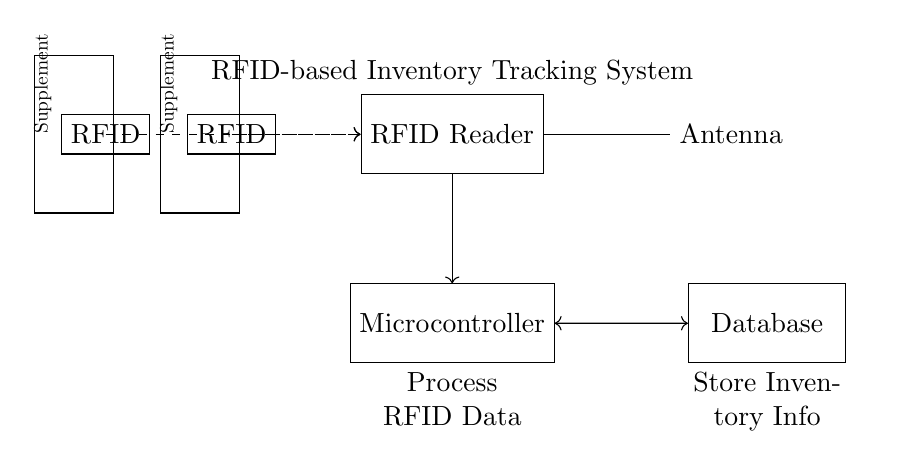What is the primary component for reading RFID tags? The primary component used for reading RFID tags in this circuit is the RFID Reader, which is depicted as a rectangle at the top of the diagram.
Answer: RFID Reader What does the microcontroller do in this system? The microcontroller processes the RFID data collected from the RFID Reader, which connects to it via a directed arrow, indicating data flow.
Answer: Process RFID Data How many supplement bottles are represented in the diagram? There are two supplement bottles shown in the circuit diagram, each with an RFID tag attached, marked by the rectangles on the left side.
Answer: Two What type of connection exists between the microcontroller and the database? The connection between the microcontroller and the database is a bidirectional connection, shown as a double-headed arrow indicating two-way data communication.
Answer: Bidirectional What is the purpose of the antenna in this circuit? The antenna is used to facilitate communication between the RFID Reader and the RFID tags on the supplement bottles, allowing the reader to capture data from the tags.
Answer: Facilitate communication What is the role of the database within the system? The database is responsible for storing inventory information that is processed by the microcontroller from the RFID data collected by the reader.
Answer: Store Inventory Info 